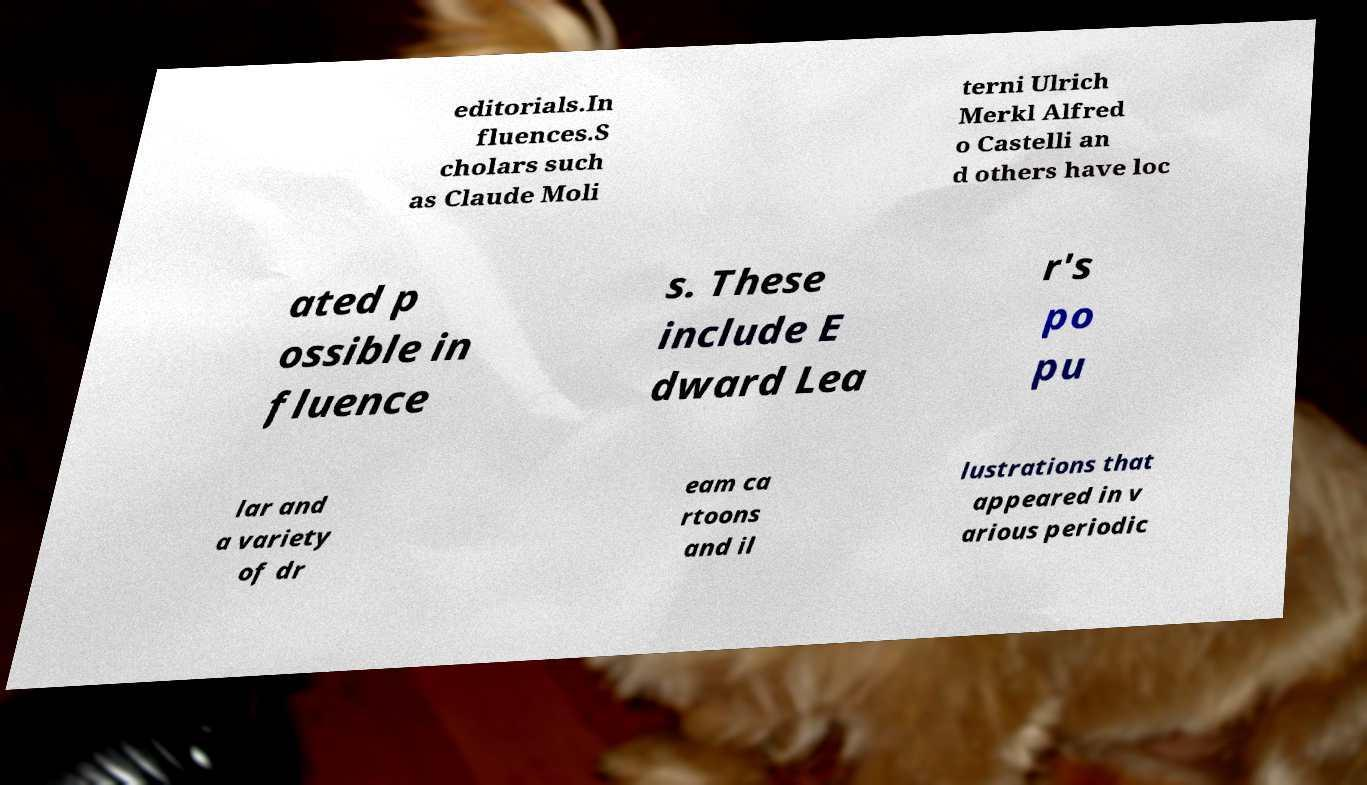I need the written content from this picture converted into text. Can you do that? editorials.In fluences.S cholars such as Claude Moli terni Ulrich Merkl Alfred o Castelli an d others have loc ated p ossible in fluence s. These include E dward Lea r's po pu lar and a variety of dr eam ca rtoons and il lustrations that appeared in v arious periodic 